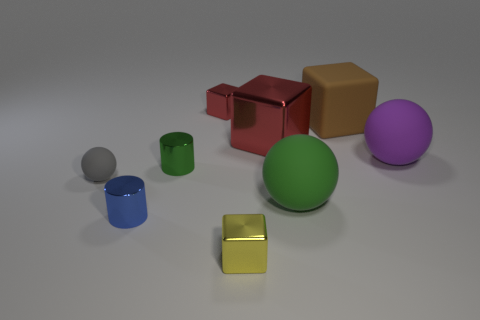What number of spheres are either gray things or tiny blue things?
Offer a very short reply. 1. There is a cube that is the same color as the large metallic object; what is it made of?
Keep it short and to the point. Metal. How many brown matte things have the same shape as the tiny yellow metal object?
Offer a very short reply. 1. Are there more small green metallic cylinders to the left of the purple ball than large purple objects to the left of the large green matte object?
Give a very brief answer. Yes. There is a cube that is behind the large brown matte cube; is its color the same as the large metallic thing?
Give a very brief answer. Yes. The blue cylinder has what size?
Your answer should be compact. Small. There is a red cube that is the same size as the green shiny object; what is it made of?
Make the answer very short. Metal. What is the color of the small metallic cylinder that is behind the blue metal cylinder?
Offer a terse response. Green. What number of large brown things are there?
Your answer should be very brief. 1. There is a matte thing behind the thing right of the big brown rubber object; is there a tiny thing on the left side of it?
Provide a short and direct response. Yes. 